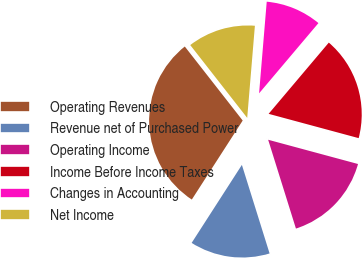<chart> <loc_0><loc_0><loc_500><loc_500><pie_chart><fcel>Operating Revenues<fcel>Revenue net of Purchased Power<fcel>Operating Income<fcel>Income Before Income Taxes<fcel>Changes in Accounting<fcel>Net Income<nl><fcel>30.33%<fcel>13.93%<fcel>15.98%<fcel>18.03%<fcel>9.84%<fcel>11.89%<nl></chart> 